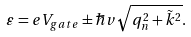<formula> <loc_0><loc_0><loc_500><loc_500>\varepsilon = e V _ { g a t e } \pm { \hbar { v } } \sqrt { q _ { n } ^ { 2 } + \tilde { k } ^ { 2 } } .</formula> 